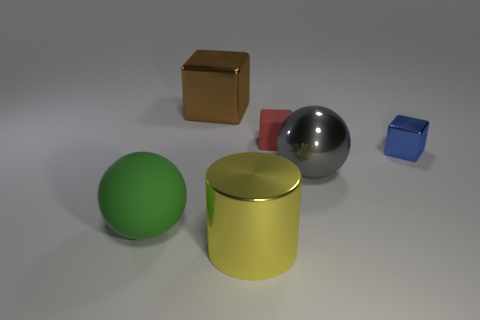Add 3 tiny green matte spheres. How many objects exist? 9 Subtract all cylinders. How many objects are left? 5 Add 3 large rubber blocks. How many large rubber blocks exist? 3 Subtract 1 blue cubes. How many objects are left? 5 Subtract all big spheres. Subtract all red cubes. How many objects are left? 3 Add 1 big gray shiny balls. How many big gray shiny balls are left? 2 